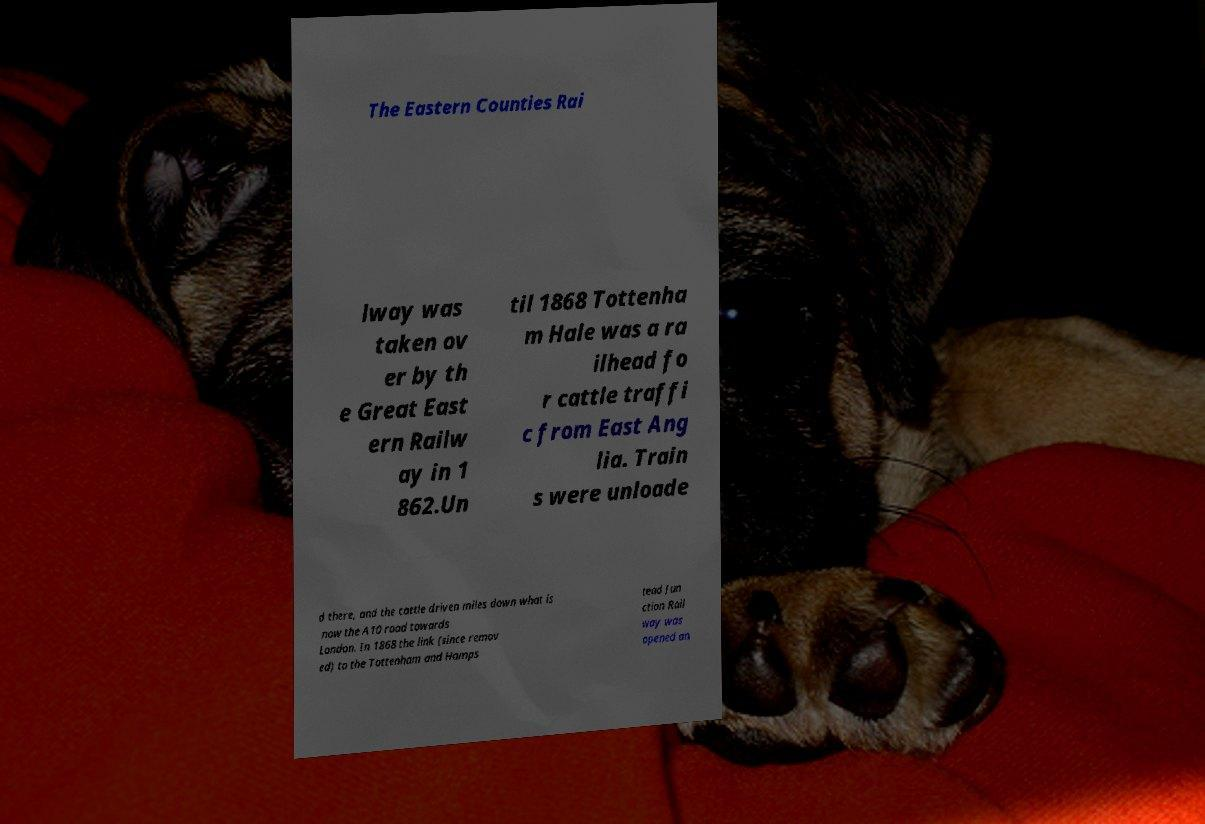Please identify and transcribe the text found in this image. The Eastern Counties Rai lway was taken ov er by th e Great East ern Railw ay in 1 862.Un til 1868 Tottenha m Hale was a ra ilhead fo r cattle traffi c from East Ang lia. Train s were unloade d there, and the cattle driven miles down what is now the A10 road towards London. In 1868 the link (since remov ed) to the Tottenham and Hamps tead Jun ction Rail way was opened an 